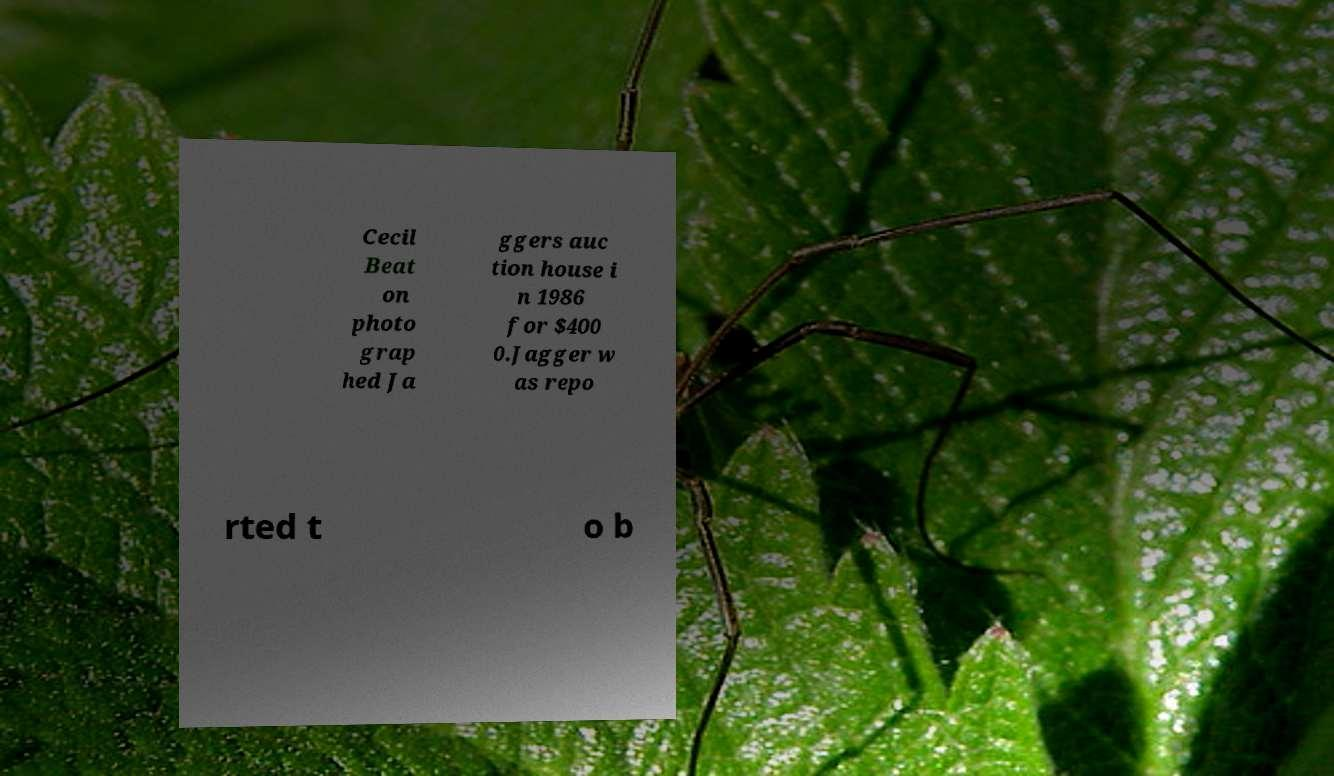Can you read and provide the text displayed in the image?This photo seems to have some interesting text. Can you extract and type it out for me? Cecil Beat on photo grap hed Ja ggers auc tion house i n 1986 for $400 0.Jagger w as repo rted t o b 